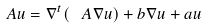Convert formula to latex. <formula><loc_0><loc_0><loc_500><loc_500>A u = \nabla ^ { t } ( \ A \nabla u ) + { b } \nabla u + a u</formula> 